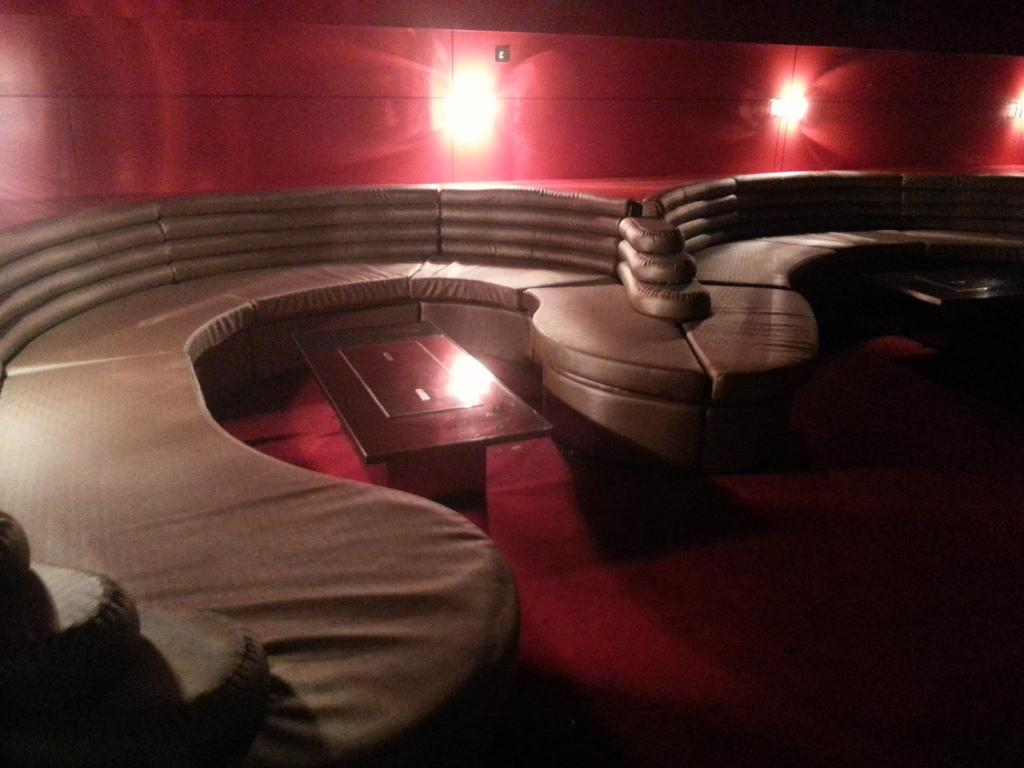What type of furniture is present in the image? There is a sofa in the image. How many tables are visible in the image? There are two tables in the image. What is on the floor in the image? There is a carpet on the floor in the image. What can be seen on the wall in the background of the image? There are lights on the wall in the background of the image. Where is the father sitting on the sofa in the image? There is no father present in the image; it only features a sofa, two tables, a carpet, and lights on the wall. What type of brick is used to build the wall with lights in the image? There is no mention of bricks in the image; it only shows a wall with lights. 